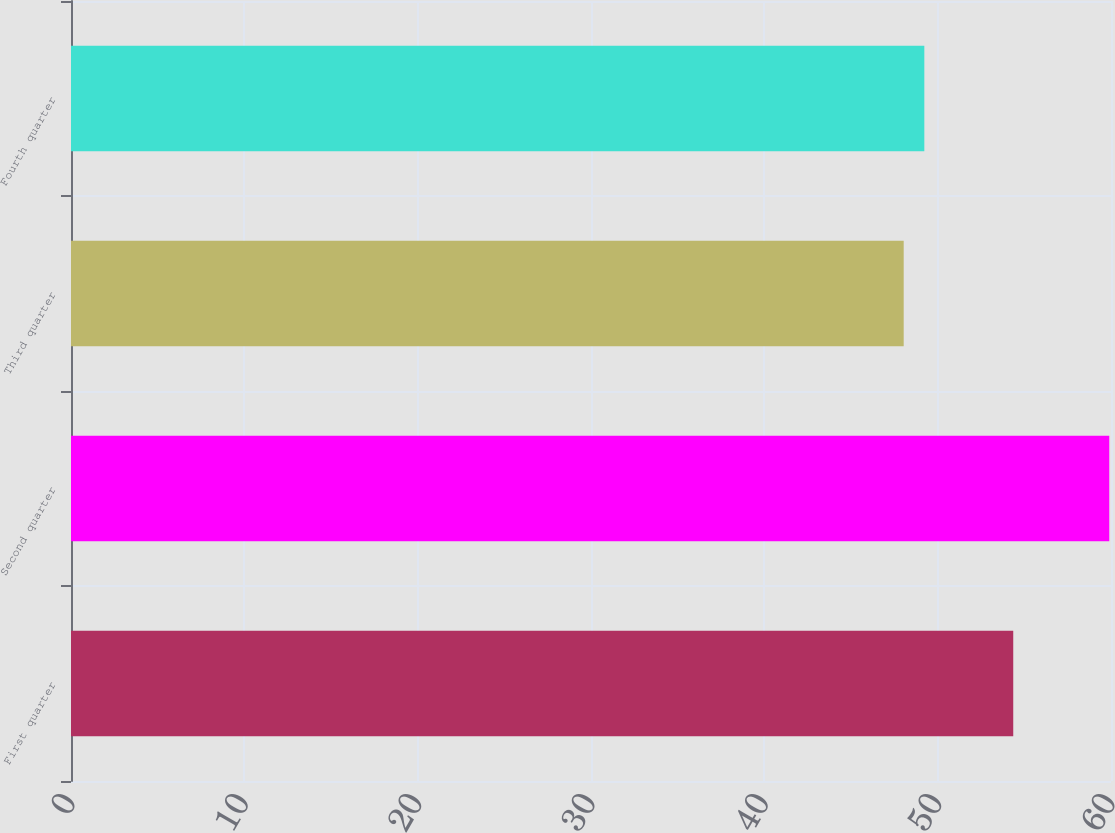Convert chart. <chart><loc_0><loc_0><loc_500><loc_500><bar_chart><fcel>First quarter<fcel>Second quarter<fcel>Third quarter<fcel>Fourth quarter<nl><fcel>54.36<fcel>59.9<fcel>48.04<fcel>49.23<nl></chart> 